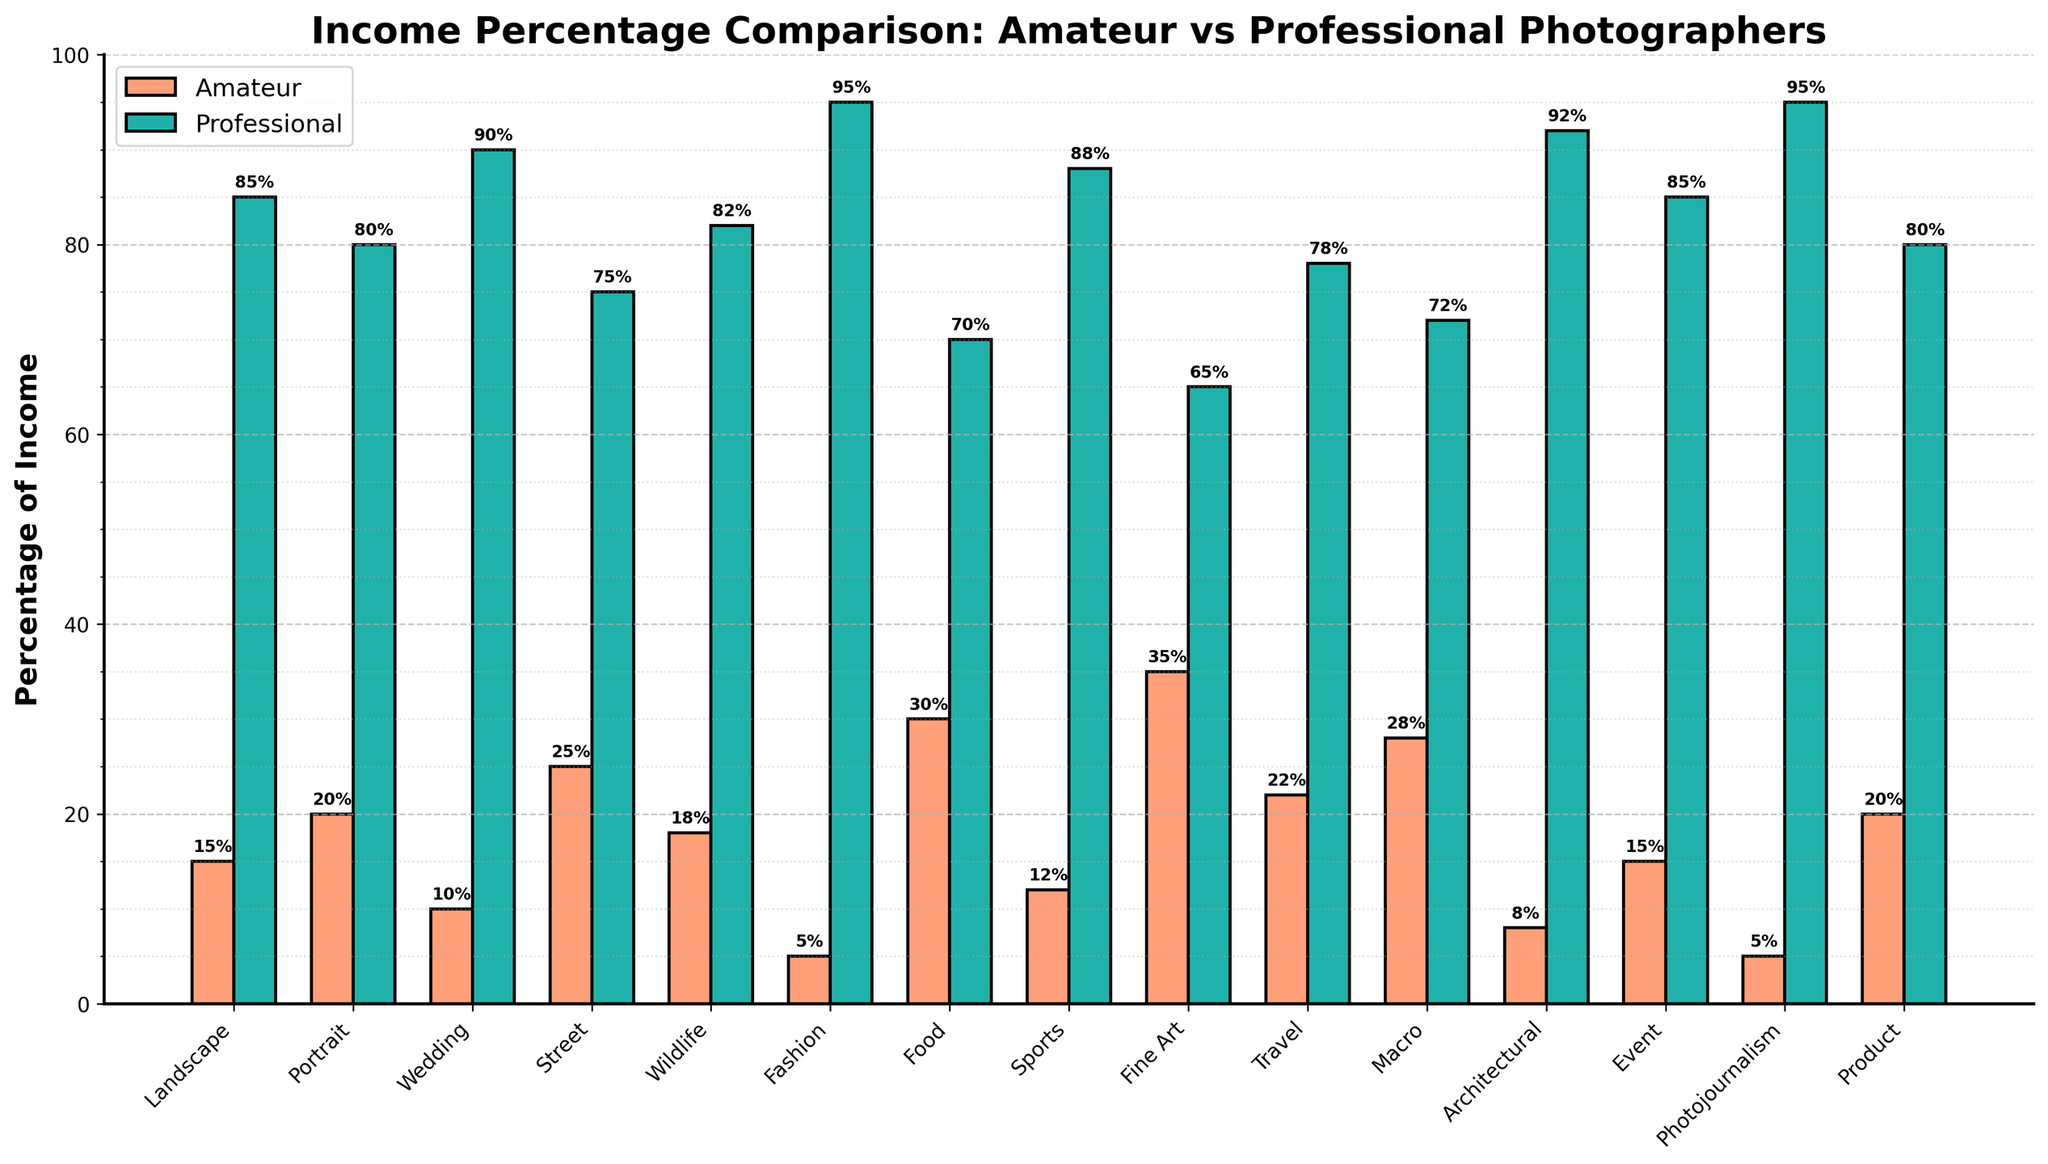Which genre has the highest amateur income percentage? The highest amateur income percentage can be determined by looking for the tallest bar in the amateur category, which is marked in red. The "Fine Art" genre has the tallest red bar at 35%.
Answer: Fine Art Which genre has the lowest professional income percentage? The lowest professional income percentage can be identified by finding the shortest bar in the professional category, which is marked in green. The "Food" genre has the shortest green bar at 70%.
Answer: Food How much higher is the professional income percentage in the fashion genre compared to the amateur income percentage in the same genre? The professional income percentage in the fashion genre is 95%, and the amateur income percentage is 5%. The difference between these two is 95% - 5% = 90%.
Answer: 90% Which genres have an amateur income percentage of at least 20%? The genres with an amateur income of at least 20% can be found by looking for red bars that reach or exceed the 20% mark. These genres are: Portrait (20%), Street (25%), Food (30%), Fine Art (35%), Travel (22%), Macro (28%), and Product (20%).
Answer: Portrait, Street, Food, Fine Art, Travel, Macro, Product What is the average amateur income percentage across all genres? To find the average amateur income percentage, sum all the amateur percentages and divide by the number of genres. The sum is 15 + 20 + 10 + 25 + 18 + 5 + 30 + 12 + 35 + 22 + 28 + 8 + 15 + 5 + 20 = 268. There are 15 genres, so the average is 268 / 15 ≈ 17.87%.
Answer: 17.87% In how many genres do professionals make 80% or more of the income? We can find the number of genres where professional photographers make at least 80% by counting the green bars that start at 80% or go higher. These genres are: Landscape, Portrait, Wedding, Street, Wildlife, Fashion, Sports, Architectural, Event, and Photojournalism. There are 10 of these genres.
Answer: 10 Which genre shows the smallest difference between amateur and professional income percentages? The smallest difference can be determined by finding the genre where the red and green bars are closest in height. The "Food" genre has the smallest difference, with amateur income at 30% and professional income at 70%, making the difference 40%.
Answer: Food What is the median professional income percentage? To find the median, list the professional income percentages in order: 65, 70, 72, 75, 78, 80, 80, 82, 85, 85, 88, 90, 92, 95, 95. As there are 15 data points, the median is the 8th value, which is 82%.
Answer: 82% How does the income percentage for amateur photographers in the "Street" genre compare to that in the "Landscape" genre? Compare the heights of the red bars for Street and Landscape genres. Amateur photographers in "Street" earn 25%, while in "Landscape" they earn 15%. Street is 10% higher than Landscape.
Answer: 10% higher If the total income in the "Wedding" genre is $1,000,000, how much of this is earned by amateur photographers? Knowing that amateur photographers earn 10% of the total income in the Wedding genre, we calculate 10% of $1,000,000: 0.10 * 1,000,000 = $100,000.
Answer: $100,000 